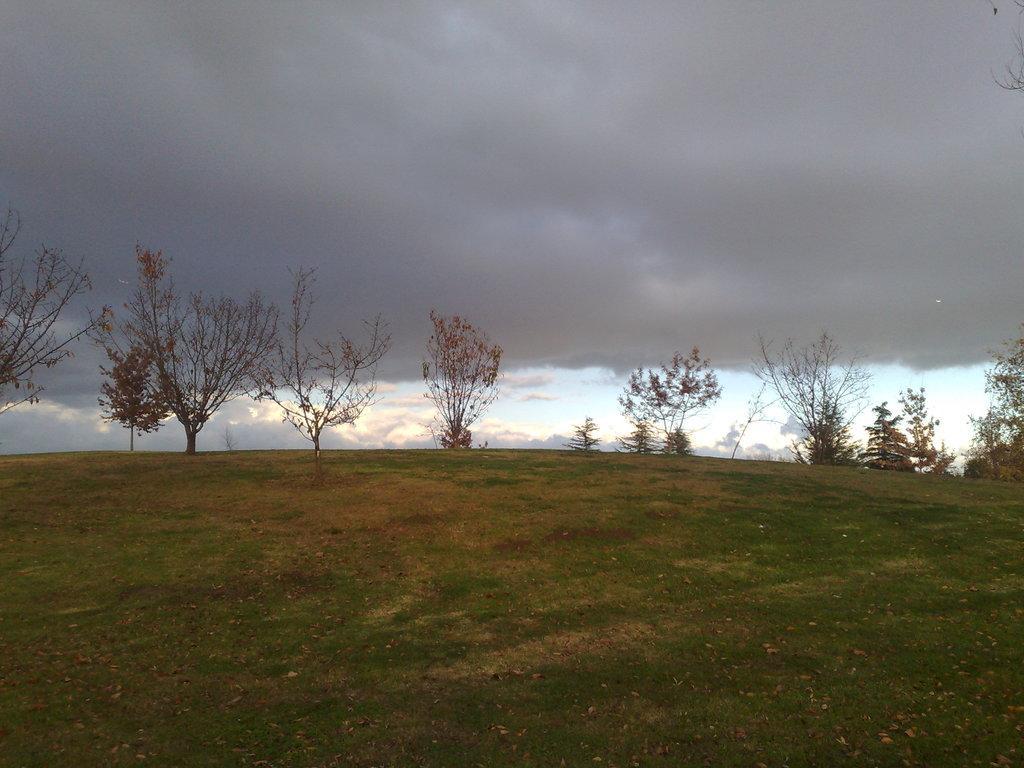How would you summarize this image in a sentence or two? In this picture we can see grass, plants, and trees. In the background there is sky with clouds. 